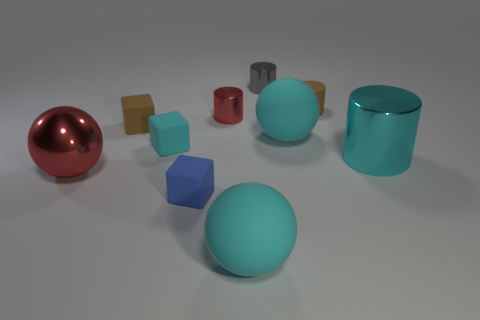How many other things are the same size as the metallic sphere?
Offer a very short reply. 3. There is a matte block that is the same color as the small matte cylinder; what size is it?
Make the answer very short. Small. What number of small cylinders have the same color as the big shiny ball?
Keep it short and to the point. 1. The small cyan rubber object has what shape?
Keep it short and to the point. Cube. What color is the matte thing that is both right of the tiny blue object and in front of the large metallic ball?
Your answer should be compact. Cyan. What is the material of the big red ball?
Keep it short and to the point. Metal. The cyan matte object left of the red cylinder has what shape?
Your answer should be very brief. Cube. There is a metal thing that is the same size as the red cylinder; what is its color?
Offer a terse response. Gray. Is the large cyan ball in front of the large cyan cylinder made of the same material as the tiny blue thing?
Your answer should be very brief. Yes. What is the size of the cyan thing that is both right of the tiny red metal cylinder and behind the cyan metallic cylinder?
Give a very brief answer. Large. 